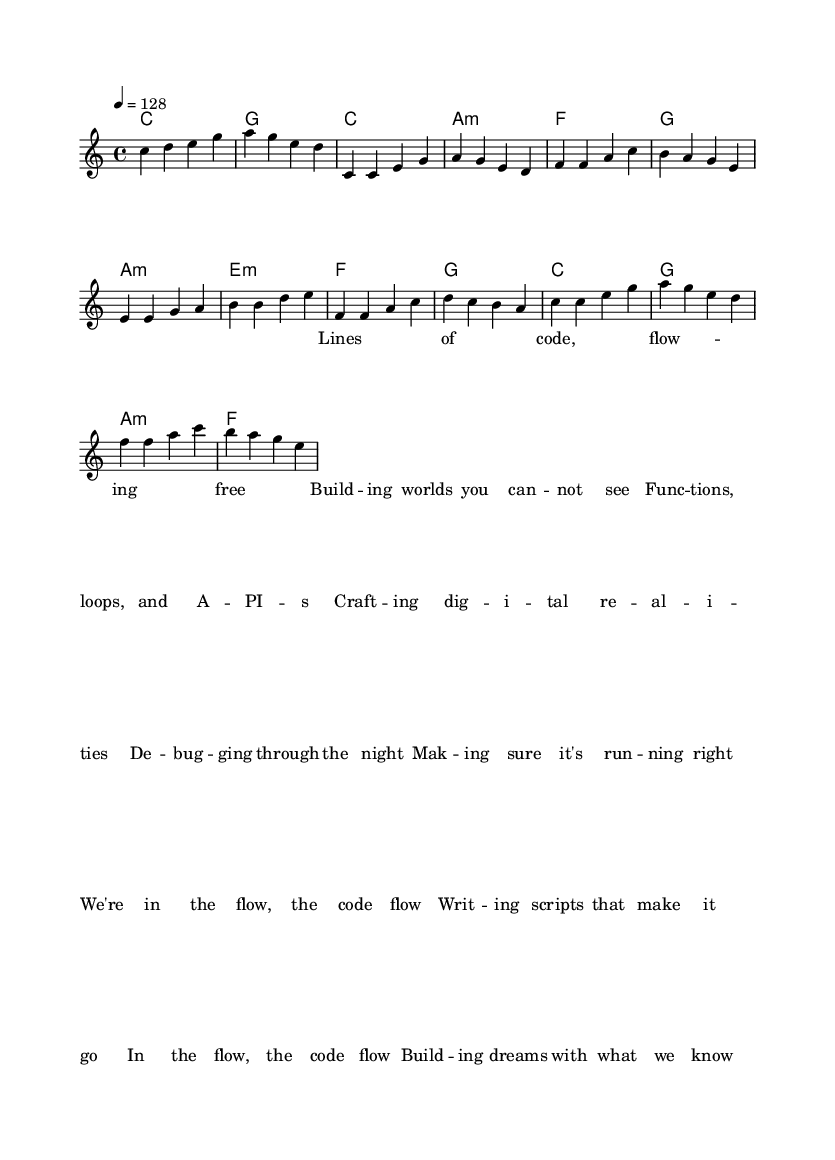what is the key signature of this music? The key signature is indicated at the beginning of the music. In this case, it is C major, which has no sharps or flats.
Answer: C major what is the time signature of this music? The time signature appears at the start of the piece. It shows that there are four beats in each measure (4/4).
Answer: 4/4 what is the tempo marking of this music? The tempo marking is found next to the global indication. It specifies that the piece should be played at a speed of 128 beats per minute.
Answer: 128 how many measures are there in the chorus? To determine this, we can count the measures explicitly written under the chorus section of the music. There are four measures in the chorus.
Answer: 4 what chord follows the first measure of the pre-chorus? The pre-chorus starts after the verse, and the first chord in the pre-chorus is identified in the chord progression. It is an A minor chord.
Answer: A minor how does the lyrical content of this song align with its musical style? The lyrics focus on coding and digital creation, which reflect the upbeat and electronic style of pop music characterized by modern themes. The integration of technical language into the lyrics aligns well with the energetic pop genre.
Answer: Coding-inspired lyrics which musical section includes lyrics about debugging? The lyrics specifically mentioning debugging appear in the pre-chorus part of the music, as indicated by the structure of the song.
Answer: Pre-Chorus 